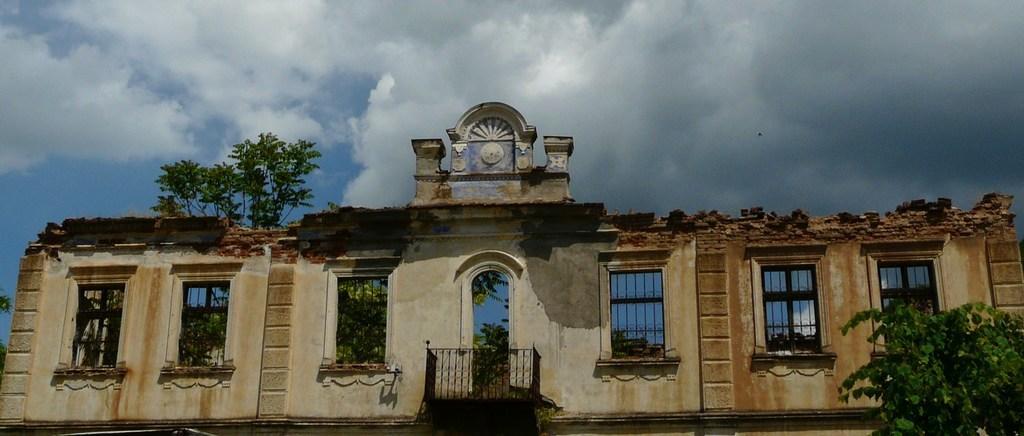Describe this image in one or two sentences. In this picture I can see the wall in front, on which there are windows and I can see few trees. In the background I can see the sky, which is cloudy. 